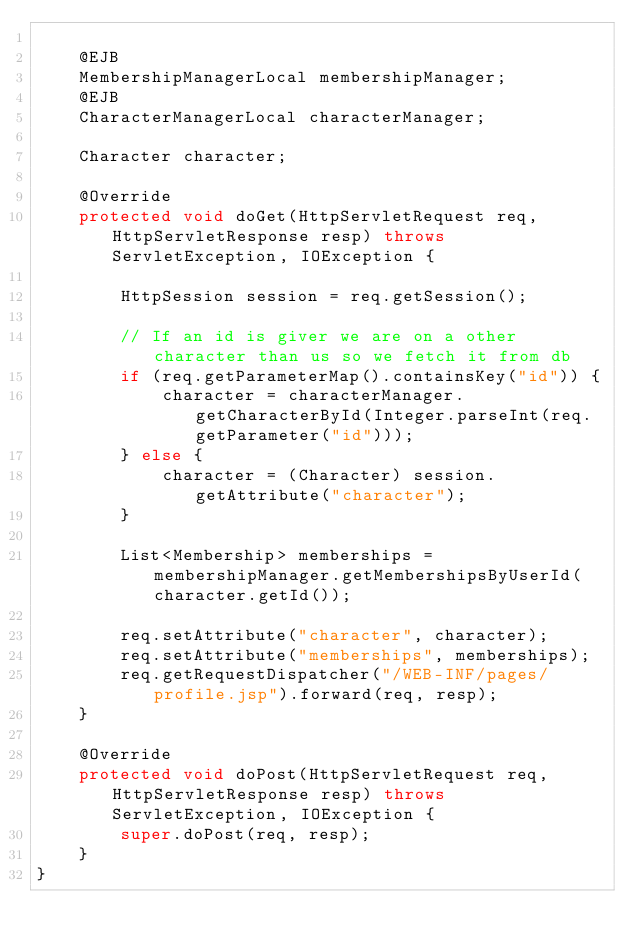<code> <loc_0><loc_0><loc_500><loc_500><_Java_>
    @EJB
    MembershipManagerLocal membershipManager;
    @EJB
    CharacterManagerLocal characterManager;

    Character character;

    @Override
    protected void doGet(HttpServletRequest req, HttpServletResponse resp) throws ServletException, IOException {

        HttpSession session = req.getSession();

        // If an id is giver we are on a other character than us so we fetch it from db
        if (req.getParameterMap().containsKey("id")) {
            character = characterManager.getCharacterById(Integer.parseInt(req.getParameter("id")));
        } else {
            character = (Character) session.getAttribute("character");
        }

        List<Membership> memberships = membershipManager.getMembershipsByUserId(character.getId());

        req.setAttribute("character", character);
        req.setAttribute("memberships", memberships);
        req.getRequestDispatcher("/WEB-INF/pages/profile.jsp").forward(req, resp);
    }

    @Override
    protected void doPost(HttpServletRequest req, HttpServletResponse resp) throws ServletException, IOException {
        super.doPost(req, resp);
    }
}
</code> 